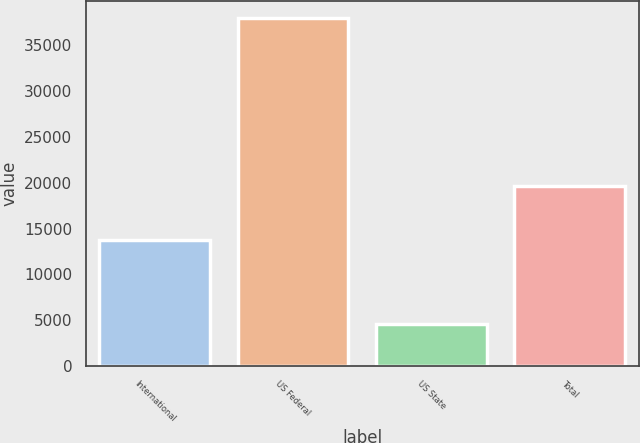Convert chart. <chart><loc_0><loc_0><loc_500><loc_500><bar_chart><fcel>International<fcel>US Federal<fcel>US State<fcel>Total<nl><fcel>13792<fcel>37956<fcel>4568<fcel>19596<nl></chart> 